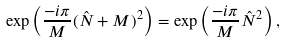<formula> <loc_0><loc_0><loc_500><loc_500>\exp \left ( \frac { - i \pi } { M } ( \hat { N } + M ) ^ { 2 } \right ) = \exp \left ( \frac { - i \pi } { M } \hat { N } ^ { 2 } \right ) ,</formula> 